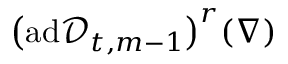<formula> <loc_0><loc_0><loc_500><loc_500>\left ( a d \ m a t h s c r { D } _ { t , m - 1 } \right ) ^ { r } ( \nabla )</formula> 